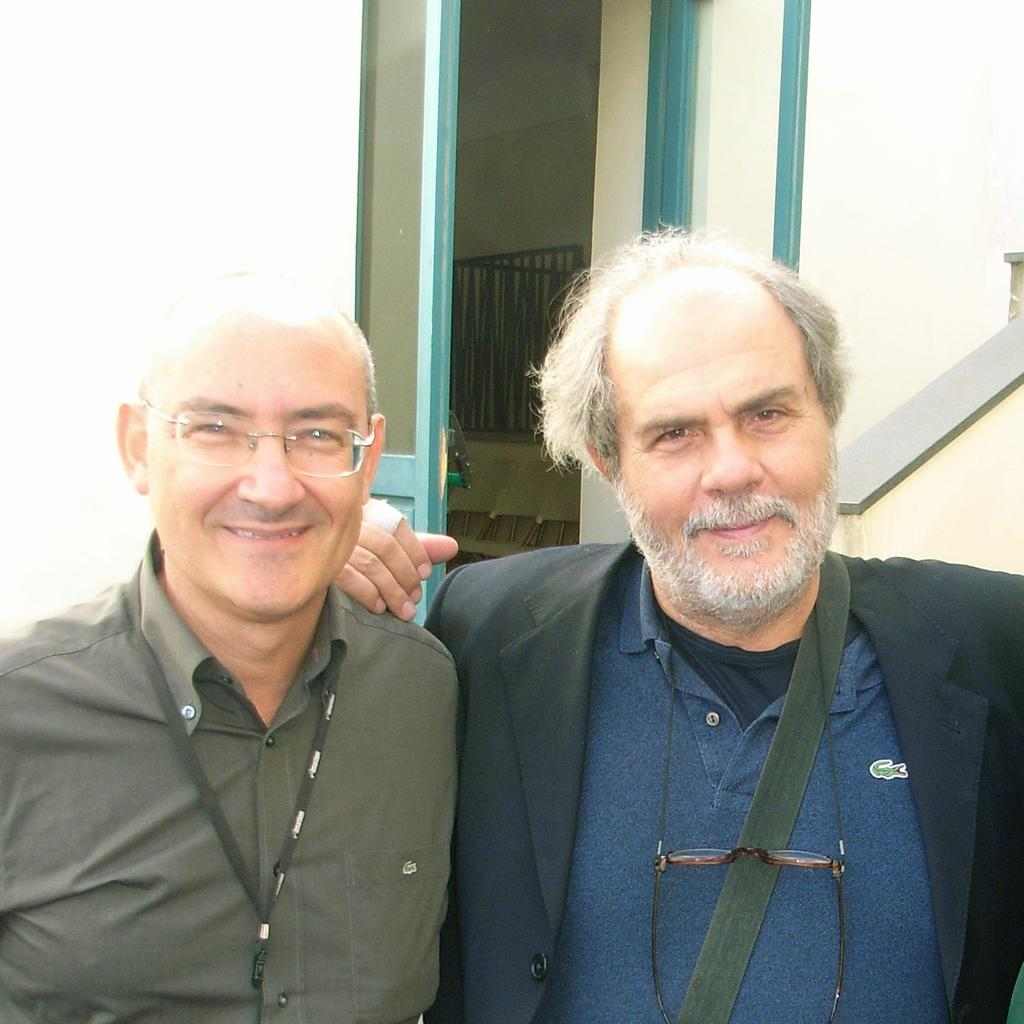How many people are in the image? There are two men in the image. What expression do the men have? The men are smiling. What can be seen in the background of the image? There are walls, a door, and a grille in the background of the image. Can you describe the setting where the men are located? The men are in a room with walls, a door, and a grille visible in the background. What type of ray is visible in the image? There is no ray present in the image. What color are the jeans worn by the men in the image? The provided facts do not mention the color of the men's clothing, so we cannot determine the color of their jeans. 